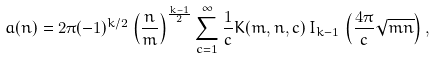Convert formula to latex. <formula><loc_0><loc_0><loc_500><loc_500>a ( n ) & = 2 \pi ( - 1 ) ^ { k / 2 } \left ( \frac { n } { m } \right ) ^ { \frac { k - 1 } { 2 } } \sum _ { c = 1 } ^ { \infty } \frac { 1 } { c } K ( m , n , c ) \, I _ { k - 1 } \, \left ( \frac { 4 \pi } { c } \sqrt { m n } \right ) ,</formula> 